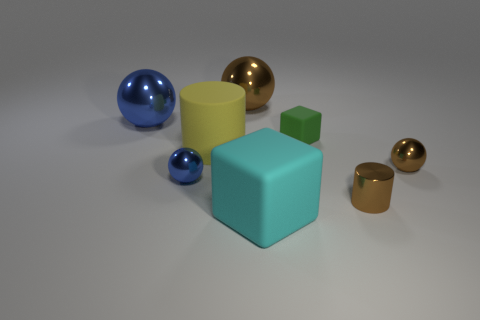Are there any other things that are the same color as the tiny cylinder?
Provide a short and direct response. Yes. How many yellow things are matte things or tiny cylinders?
Your response must be concise. 1. Are there fewer big matte cylinders behind the big cylinder than red matte things?
Provide a short and direct response. No. What number of large blocks are in front of the blue metallic thing in front of the small block?
Your response must be concise. 1. What number of other things are the same size as the cyan block?
Your answer should be compact. 3. How many things are tiny matte things or shiny balls that are behind the small brown sphere?
Give a very brief answer. 3. Are there fewer matte blocks than brown metallic objects?
Your answer should be very brief. Yes. What is the color of the large matte thing that is to the left of the large brown metallic object behind the big matte cylinder?
Make the answer very short. Yellow. There is a cyan thing that is the same shape as the small green matte object; what material is it?
Keep it short and to the point. Rubber. What number of metal objects are either small brown spheres or small blue objects?
Offer a terse response. 2. 